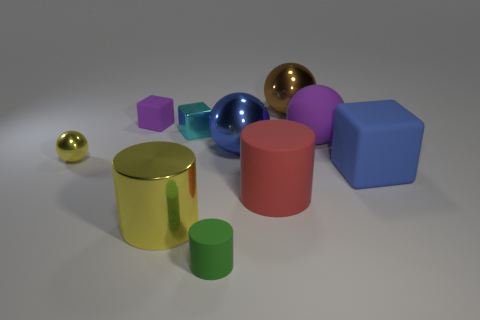Subtract all big cylinders. How many cylinders are left? 1 Subtract all green cylinders. How many cylinders are left? 2 Subtract all purple blocks. Subtract all green cylinders. How many blocks are left? 2 Subtract 0 gray balls. How many objects are left? 10 Subtract all spheres. How many objects are left? 6 Subtract all brown spheres. How many blue blocks are left? 1 Subtract all big brown metallic spheres. Subtract all small green cylinders. How many objects are left? 8 Add 6 big red matte cylinders. How many big red matte cylinders are left? 7 Add 5 big green balls. How many big green balls exist? 5 